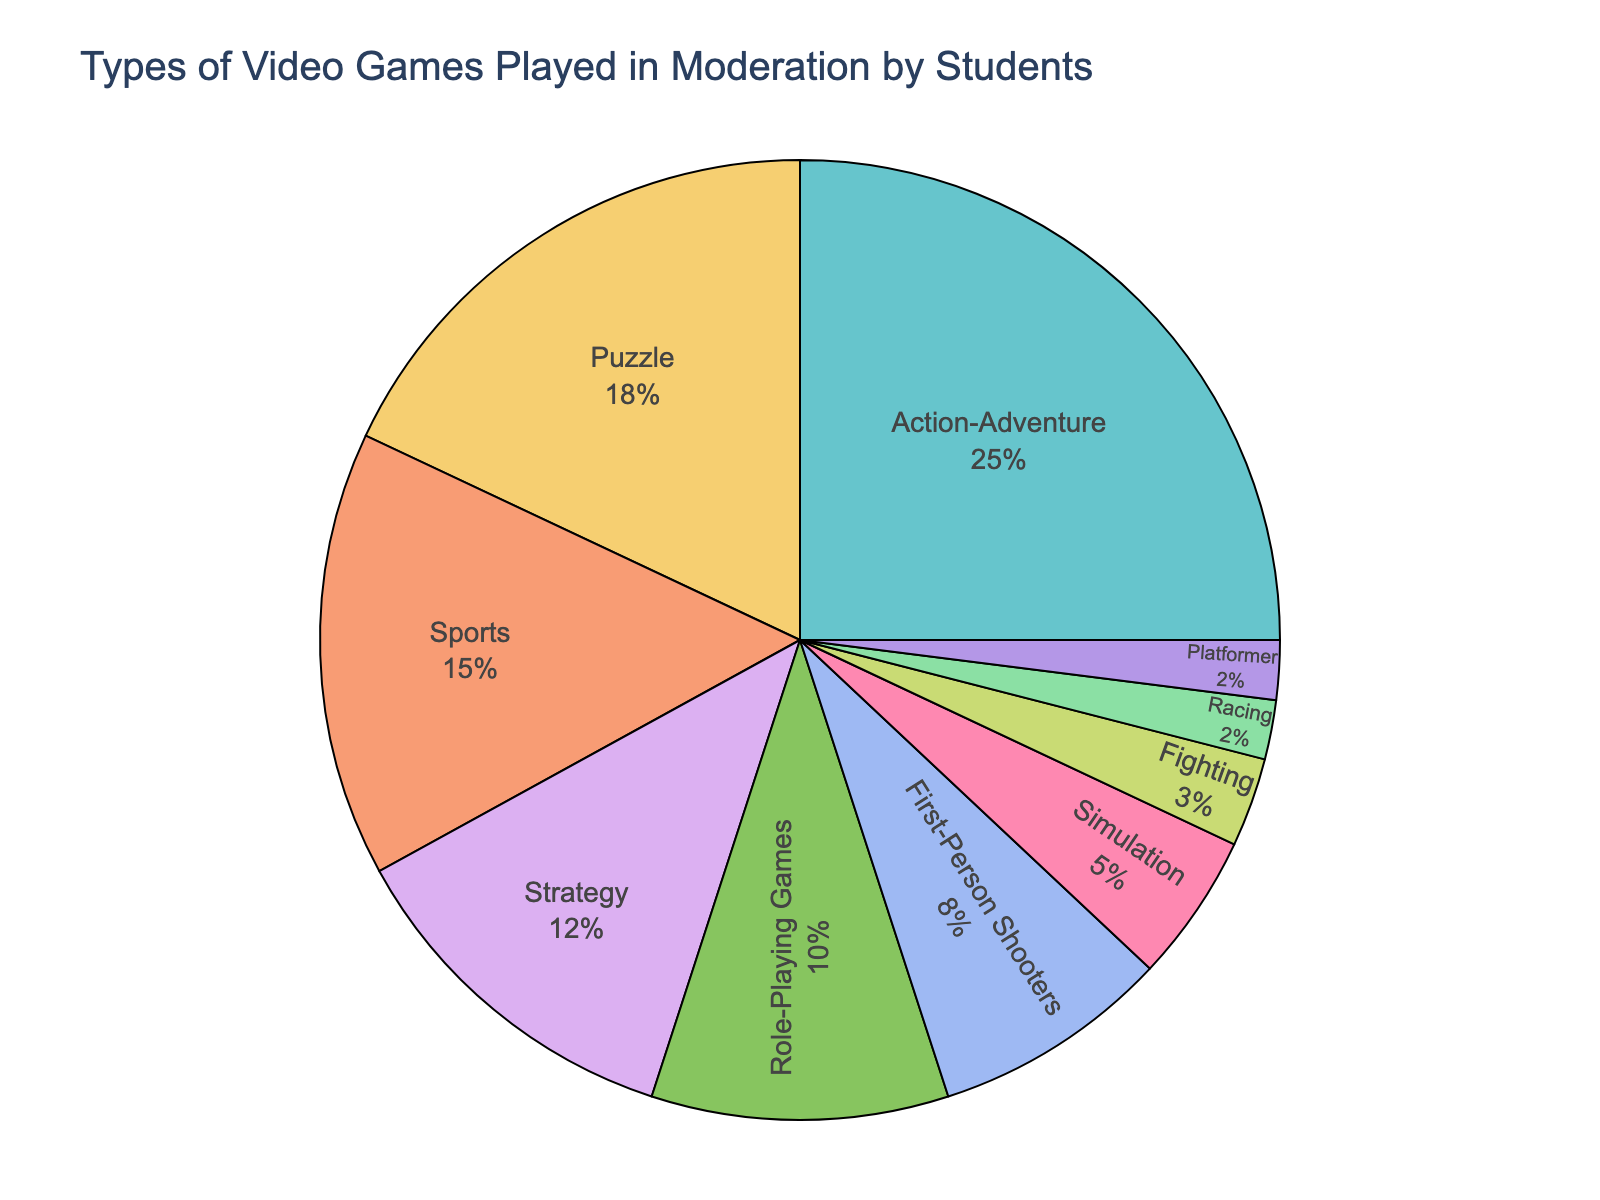Which game type has the largest percentage of students who play it in moderation? Look at the pie chart and identify the segment with the largest percentage value. "Action-Adventure" is indicated as 25%, which is the largest.
Answer: Action-Adventure What is the combined percentage of students who play Sports and Strategy games in moderation? Add the percentages of Sports (15%) and Strategy (12%) game types together. 15% + 12% = 27%
Answer: 27% Which game type has the smallest percentage of students who play it in moderation? Look at the pie chart and identify the segment with the smallest percentage value. "Racing" and "Platformer" each have 2%, but they are the smallest listed.
Answer: Racing, Platformer Between Puzzle and Role-Playing Games, which category is more favored by students, and by how much? Compare the percentages of Puzzle (18%) and Role-Playing Games (10%). Puzzle has a higher percentage by subtracting their values. 18% - 10% = 8%
Answer: Puzzle by 8% What is the total percentage of students who play either First-Person Shooters or Fighting games in moderation? Add the percentages of First-Person Shooters (8%) and Fighting (3%) game types together. 8% + 3% = 11%
Answer: 11% Identify the game type that approximately represents one-tenth of the total playtime. One-tenth (10%) of the total is indicated directly in the chart. "Role-Playing Games" matches this percentage exactly.
Answer: Role-Playing Games What percentage of students stick to non-action games (Puzzle, Sports, Strategy) in moderation? Add the percentages for Puzzle (18%), Sports (15%), and Strategy (12%) game types together. 18% + 15% + 12% = 45%
Answer: 45% How does the percentage of students playing Simulation games compare to those playing Racing and Platformer combined? Sum the percentages for Racing (2%) and Platformer (2%) and then compare to Simulation (5%). Combined result is 2% + 2% = 4%, which is less than Simulation's 5%.
Answer: Simulation is higher What percentage of the pie chart is made up by the three least popular game types combined? Sum the percentages of Racing (2%), Platformer (2%), and Fighting (3%). 2% + 2% + 3% = 7%
Answer: 7% 